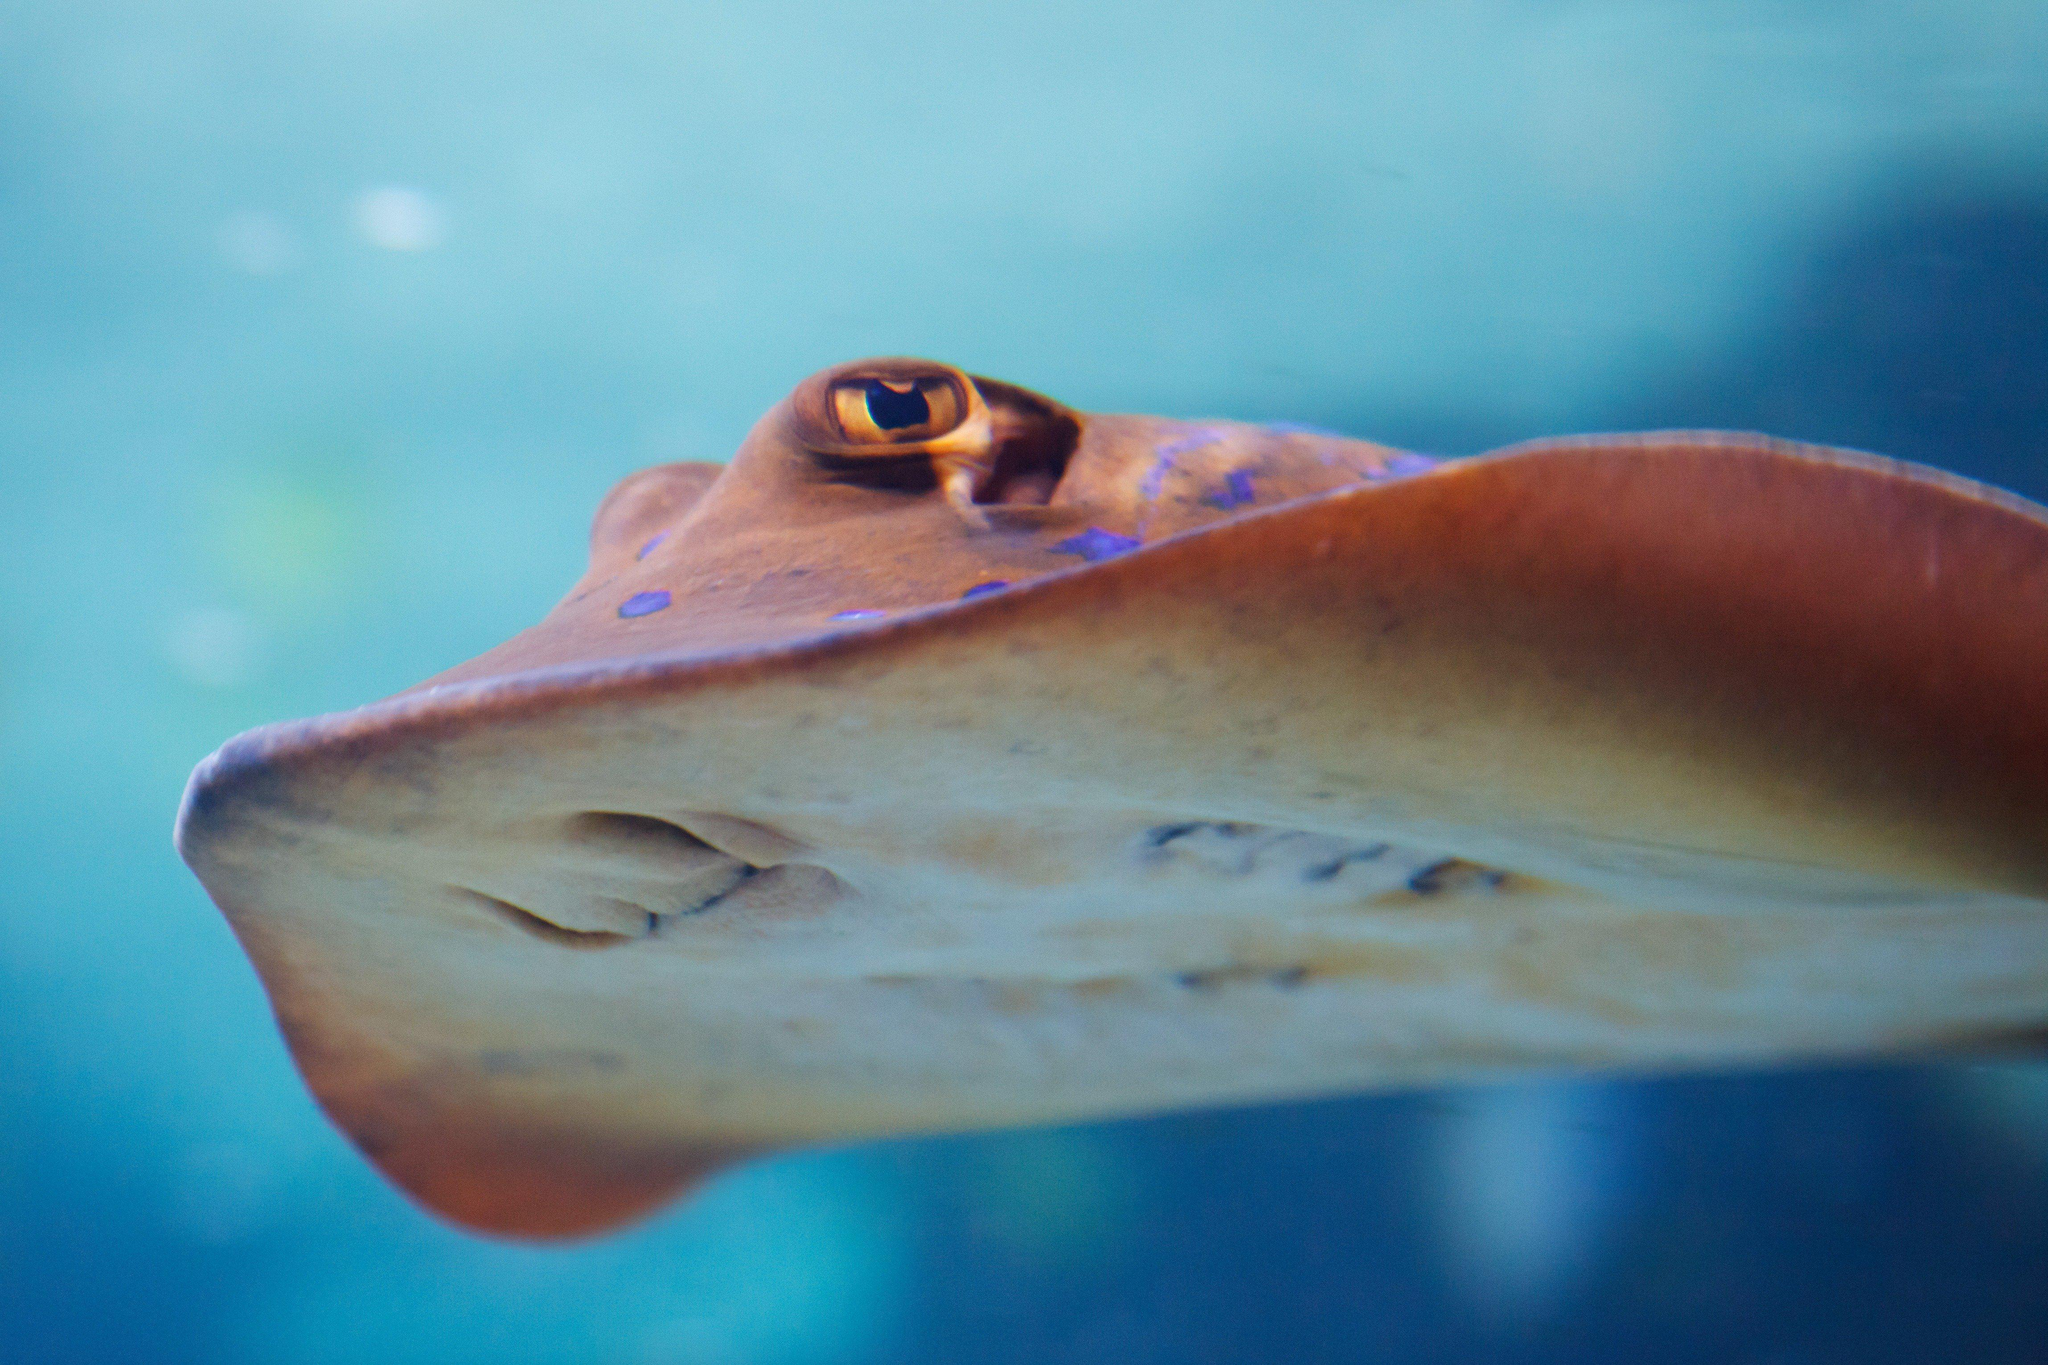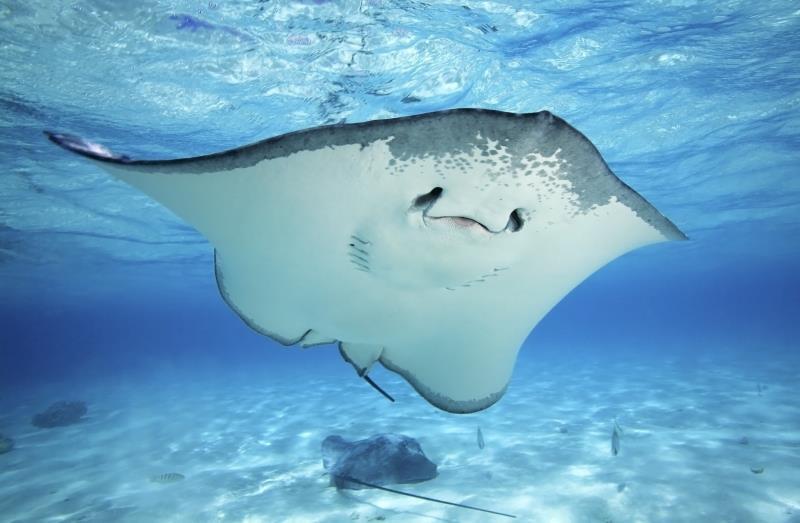The first image is the image on the left, the second image is the image on the right. Assess this claim about the two images: "The left and right image contains the same number stingrays with at least one with blue dots.". Correct or not? Answer yes or no. Yes. The first image is the image on the left, the second image is the image on the right. Considering the images on both sides, is "The ocean floor is visible in both images." valid? Answer yes or no. No. 